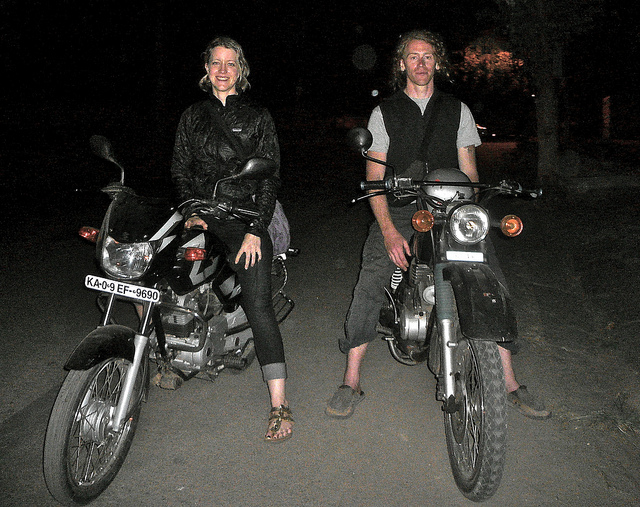What time of day does this photo seem to be taken? The photo appears to be taken at night, indicated by the surrounding darkness and the illuminated headlights of the motorcycles. 